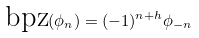Convert formula to latex. <formula><loc_0><loc_0><loc_500><loc_500>\text {bpz} ( \phi _ { n } ) = ( - 1 ) ^ { n + h } \phi _ { - n } \,</formula> 